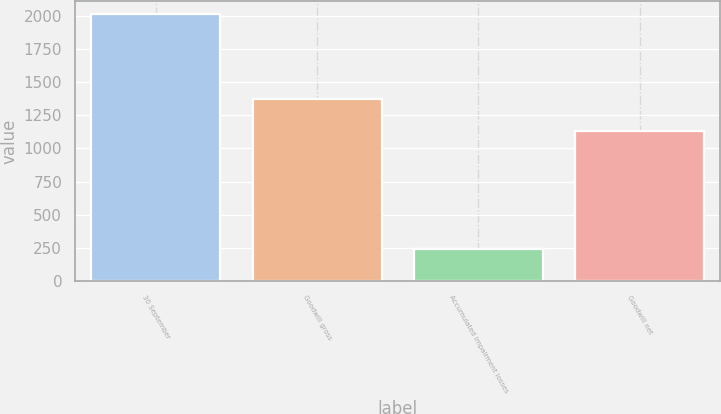<chart> <loc_0><loc_0><loc_500><loc_500><bar_chart><fcel>30 September<fcel>Goodwill gross<fcel>Accumulated impairment losses<fcel>Goodwill net<nl><fcel>2015<fcel>1375<fcel>243.7<fcel>1131.3<nl></chart> 